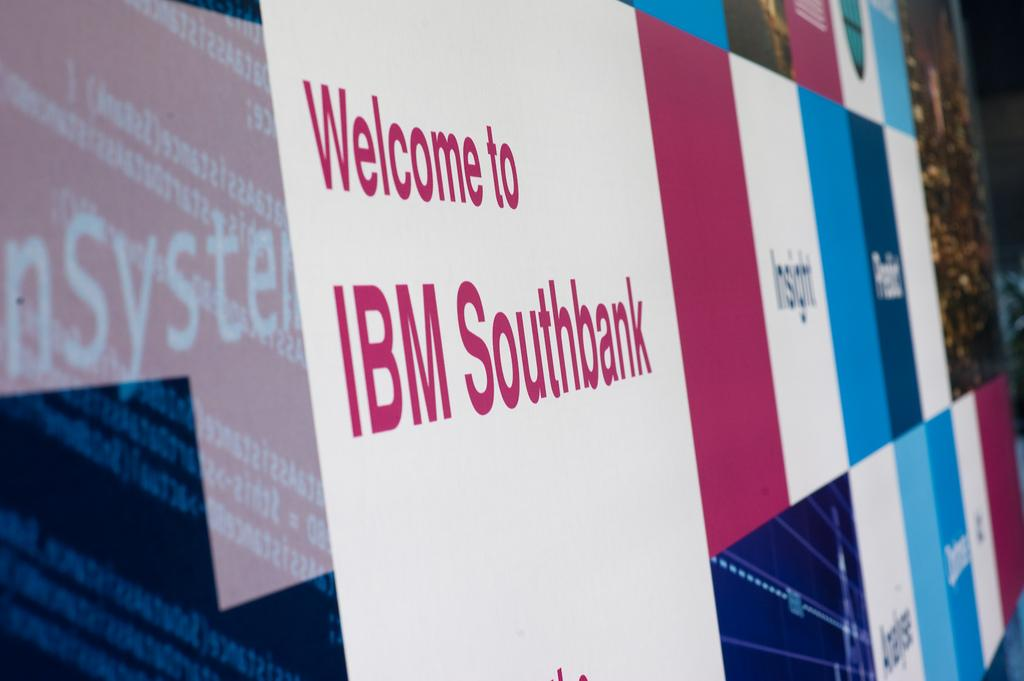<image>
Write a terse but informative summary of the picture. Screen that says Welcome to IBM Southbank in red lettering. 